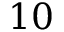<formula> <loc_0><loc_0><loc_500><loc_500>1 0</formula> 